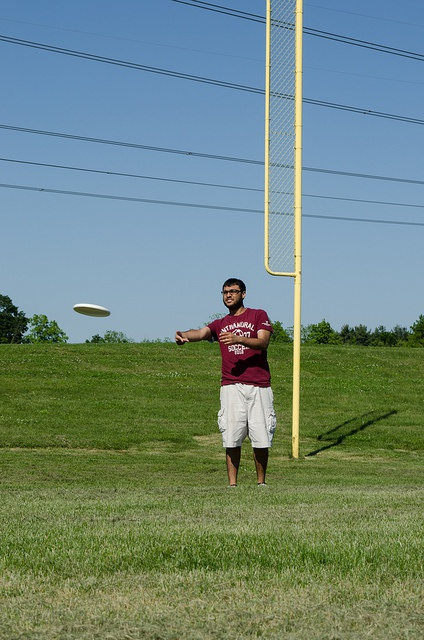Describe the objects in this image and their specific colors. I can see people in gray, maroon, lightgray, black, and darkgray tones and frisbee in gray, darkgreen, white, and darkgray tones in this image. 